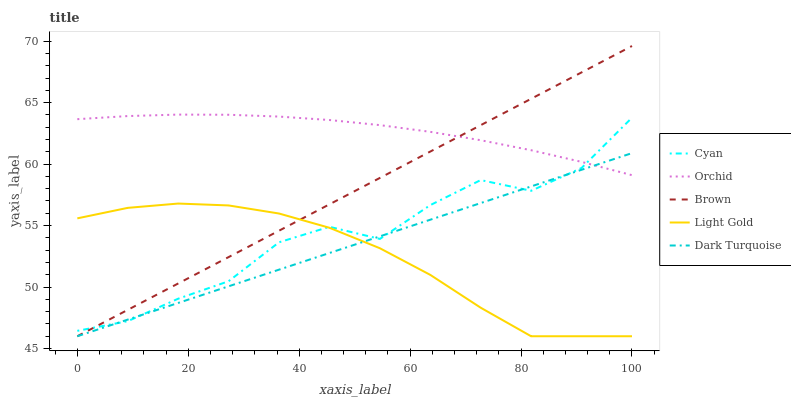Does Light Gold have the minimum area under the curve?
Answer yes or no. Yes. Does Orchid have the maximum area under the curve?
Answer yes or no. Yes. Does Brown have the minimum area under the curve?
Answer yes or no. No. Does Brown have the maximum area under the curve?
Answer yes or no. No. Is Brown the smoothest?
Answer yes or no. Yes. Is Cyan the roughest?
Answer yes or no. Yes. Is Light Gold the smoothest?
Answer yes or no. No. Is Light Gold the roughest?
Answer yes or no. No. Does Orchid have the lowest value?
Answer yes or no. No. Does Brown have the highest value?
Answer yes or no. Yes. Does Light Gold have the highest value?
Answer yes or no. No. Is Light Gold less than Orchid?
Answer yes or no. Yes. Is Orchid greater than Light Gold?
Answer yes or no. Yes. Does Dark Turquoise intersect Cyan?
Answer yes or no. Yes. Is Dark Turquoise less than Cyan?
Answer yes or no. No. Is Dark Turquoise greater than Cyan?
Answer yes or no. No. Does Light Gold intersect Orchid?
Answer yes or no. No. 